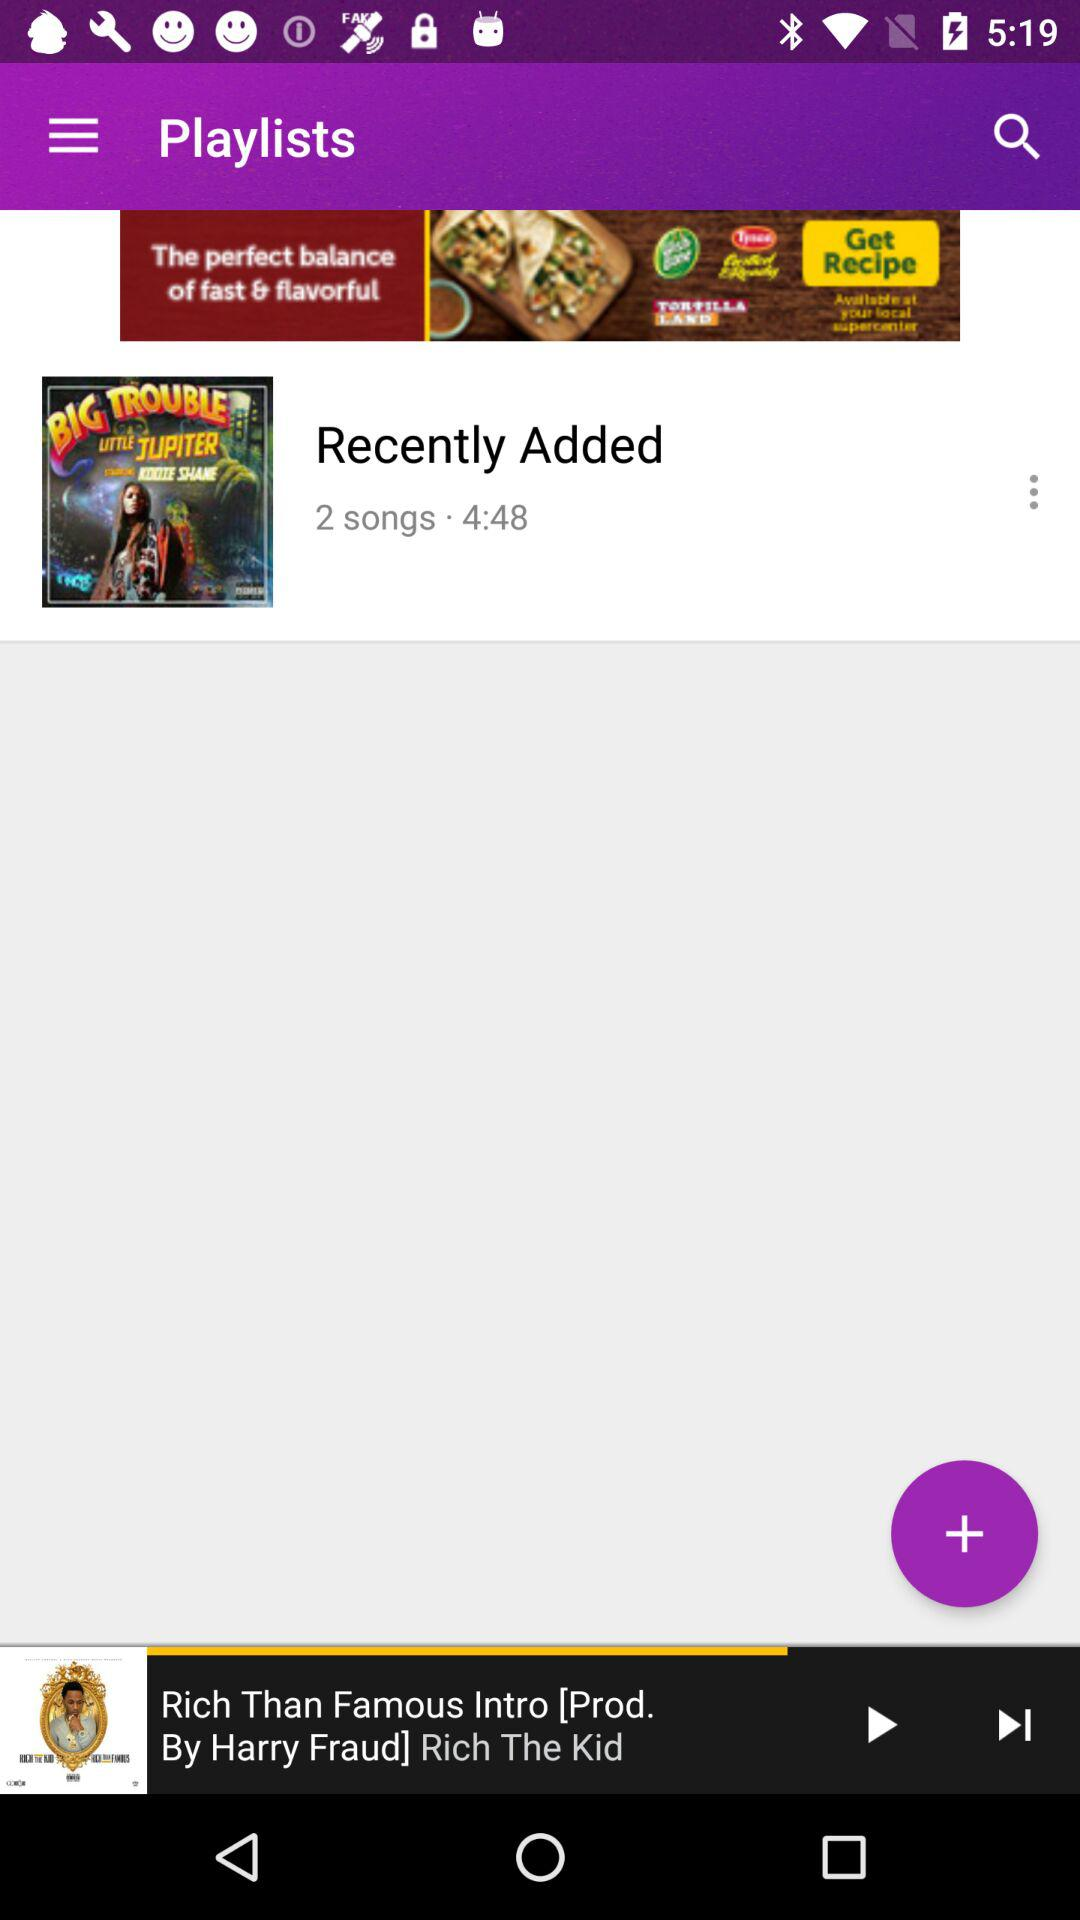What is the total duration of 2 songs added in "Recently Added"? The total duration of 2 songs added in "Recently Added" is 4 minutes and 48 seconds. 